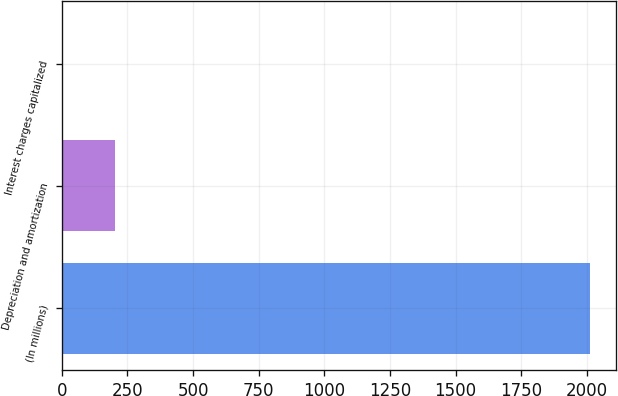Convert chart. <chart><loc_0><loc_0><loc_500><loc_500><bar_chart><fcel>(In millions)<fcel>Depreciation and amortization<fcel>Interest charges capitalized<nl><fcel>2010<fcel>201.9<fcel>1<nl></chart> 